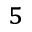<formula> <loc_0><loc_0><loc_500><loc_500>^ { 5 }</formula> 